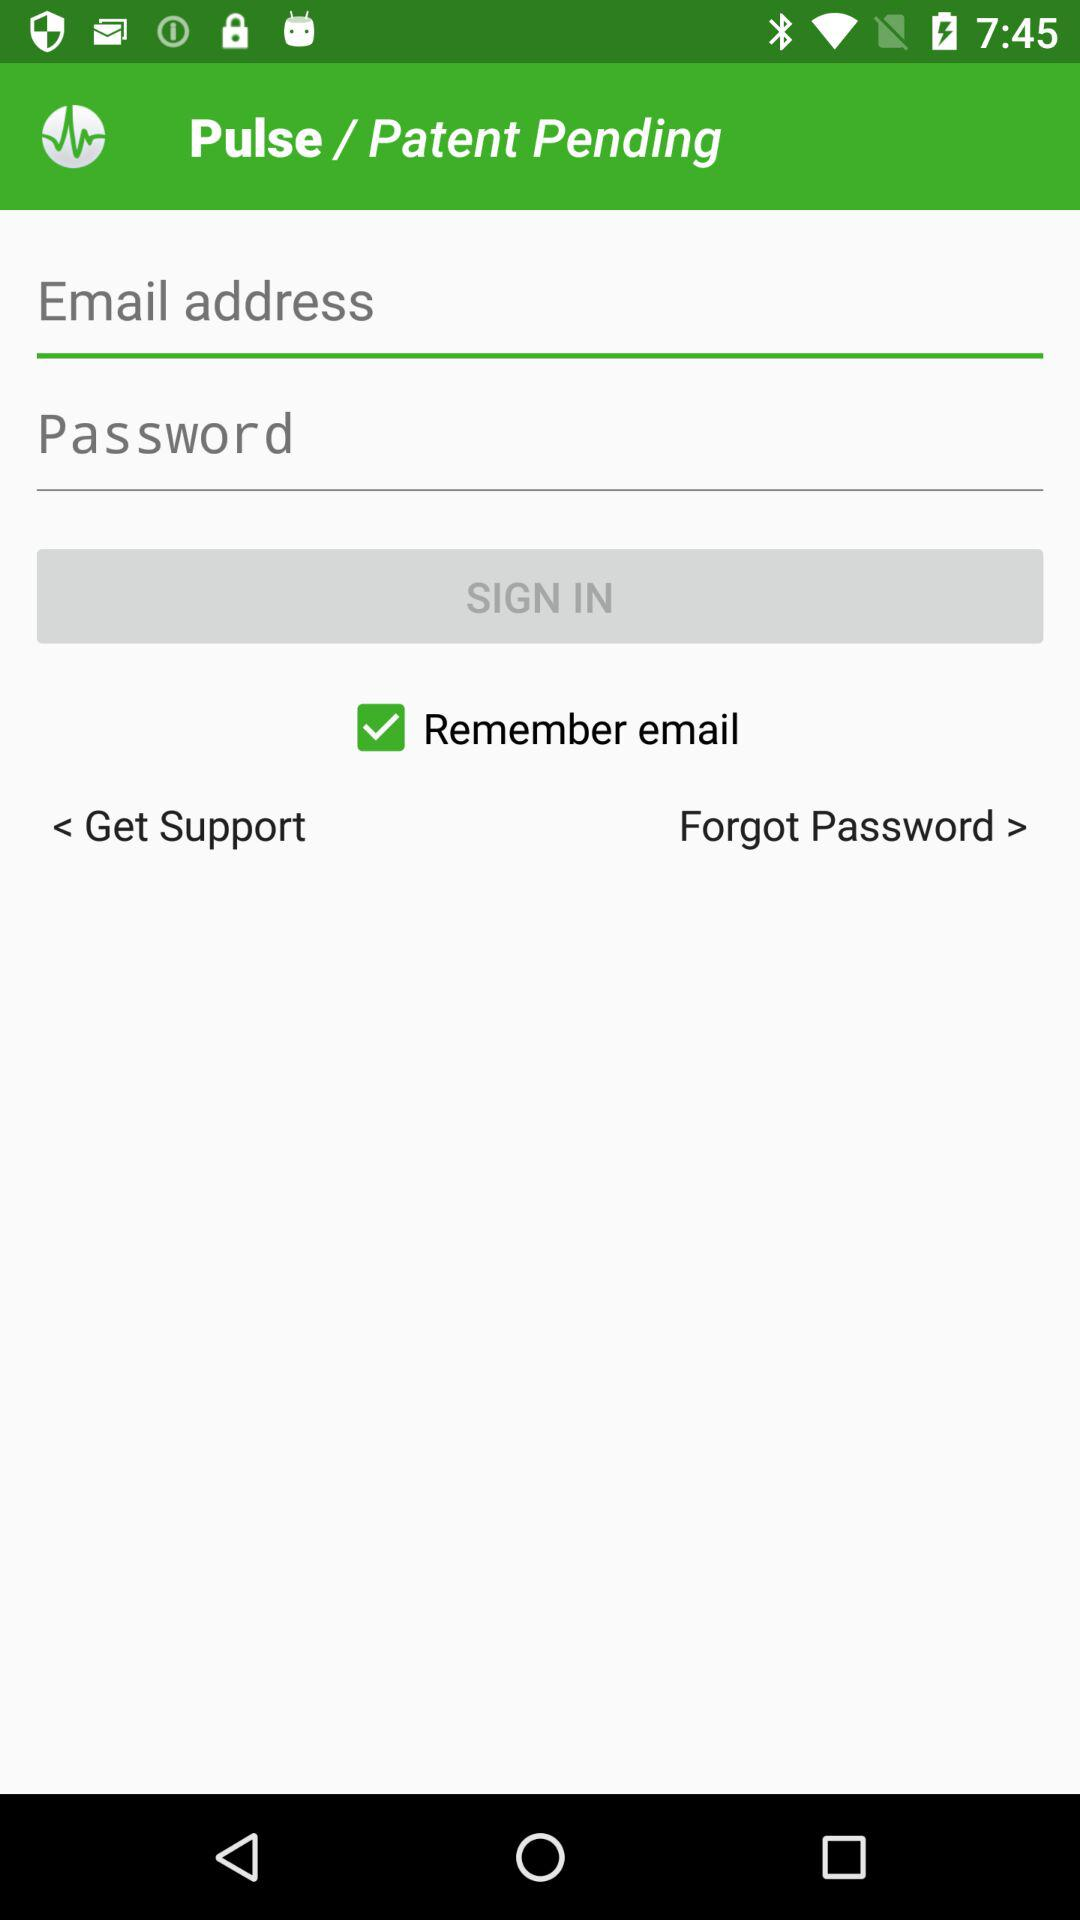How many input fields are on this page?
Answer the question using a single word or phrase. 2 